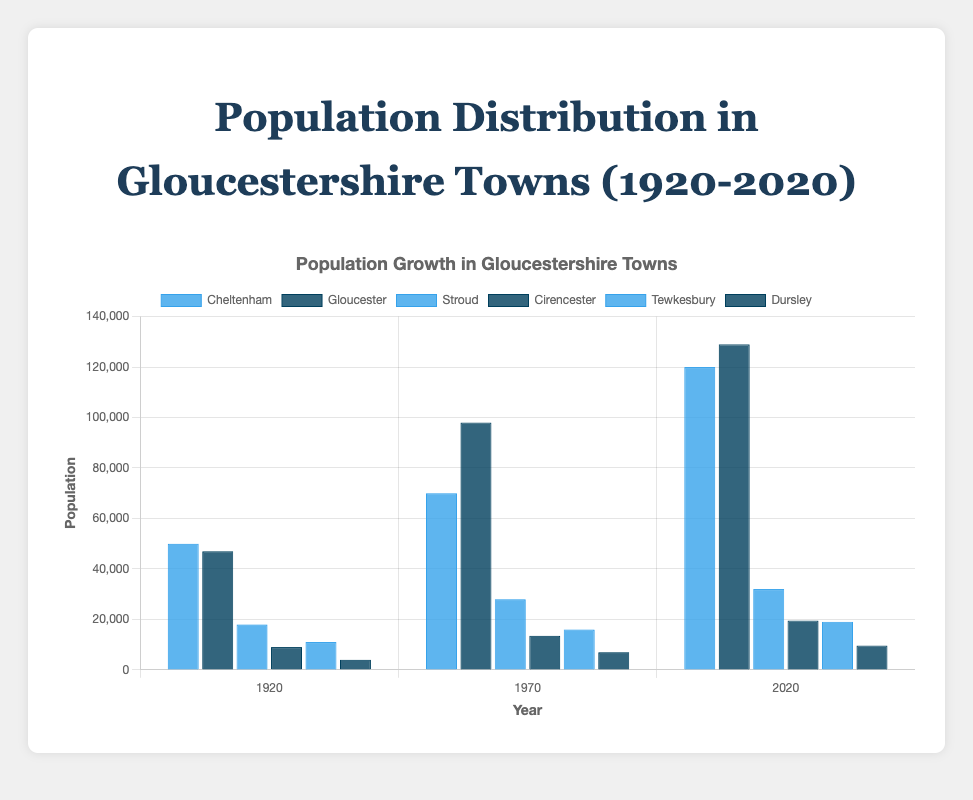Which town had the highest population in 2020? By observing the height of the bars for the year 2020, the bar representing Gloucester is the tallest.
Answer: Gloucester Which town had a greater population growth between 1920 and 2020: Cheltenham or Stroud? We calculate the population growth for both towns: Cheltenham grew from 50,000 in 1920 to 120,000 in 2020 (growth of 70,000), and Stroud grew from 18,000 in 1920 to 32,000 in 2020 (growth of 14,000). Cheltenham had a greater increase.
Answer: Cheltenham What is the total population of Gloucester and Cheltenham in 2020? The population of Gloucester in 2020 is 129,000, and the population of Cheltenham in 2020 is 120,000. Adding these together gives 129,000 + 120,000 = 249,000.
Answer: 249,000 Which town had the smallest population in 1920, and what was that population? By observing the smallest bar for the year 1920, Dursley is the town with the smallest population, which was 4,000.
Answer: Dursley, 4,000 Between which two consecutive years did Cirencester experience the highest population growth, and what was the amount of growth? We compare the growth between the years 1920-1970 and 1970-2020 for Cirencester: from 1920 to 1970, it grew from 9,000 to 13,500 (growth of 4,500); from 1970 to 2020, it grew from 13,500 to 19,500 (growth of 6,000). Thus, the highest growth was between 1970 and 2020 with an increase of 6,000.
Answer: 1970-2020, 6,000 Which town had the most similar population in 2020, and how close were their populations? In 2020, Tewkesbury had a population of 19,000 and Cirencester had a population of 19,500, making them the most similar with a difference of 500.
Answer: Tewkesbury and Cirencester, 500 Compare the percentage growth in population from 1920 to 2020 for Cheltenham and Tewkesbury. Cheltenham's population grew from 50,000 to 120,000, which is (120,000-50,000)/50,000 * 100 = 140%. Tewkesbury's population grew from 11,000 to 19,000, which is (19,000-11,000)/11,000 * 100 = 72.7%. Cheltenham had the higher percentage growth.
Answer: Cheltenham, 140%; Tewkesbury, 72.7% What is the average population of Stroud across the three years shown? The population of Stroud in 1920, 1970, and 2020 is 18,000, 28,000, and 32,000 respectively. The average is (18,000 + 28,000 + 32,000) / 3 = 26,000.
Answer: 26,000 Which town has seen more than double its population from 1920 to 2020? Gloucester grew from 47,000 in 1920 to 129,000 in 2020, and Cheltenham grew from 50,000 in 1920 to 120,000 in 2020, both more than double their populations.
Answer: Gloucester, Cheltenham 